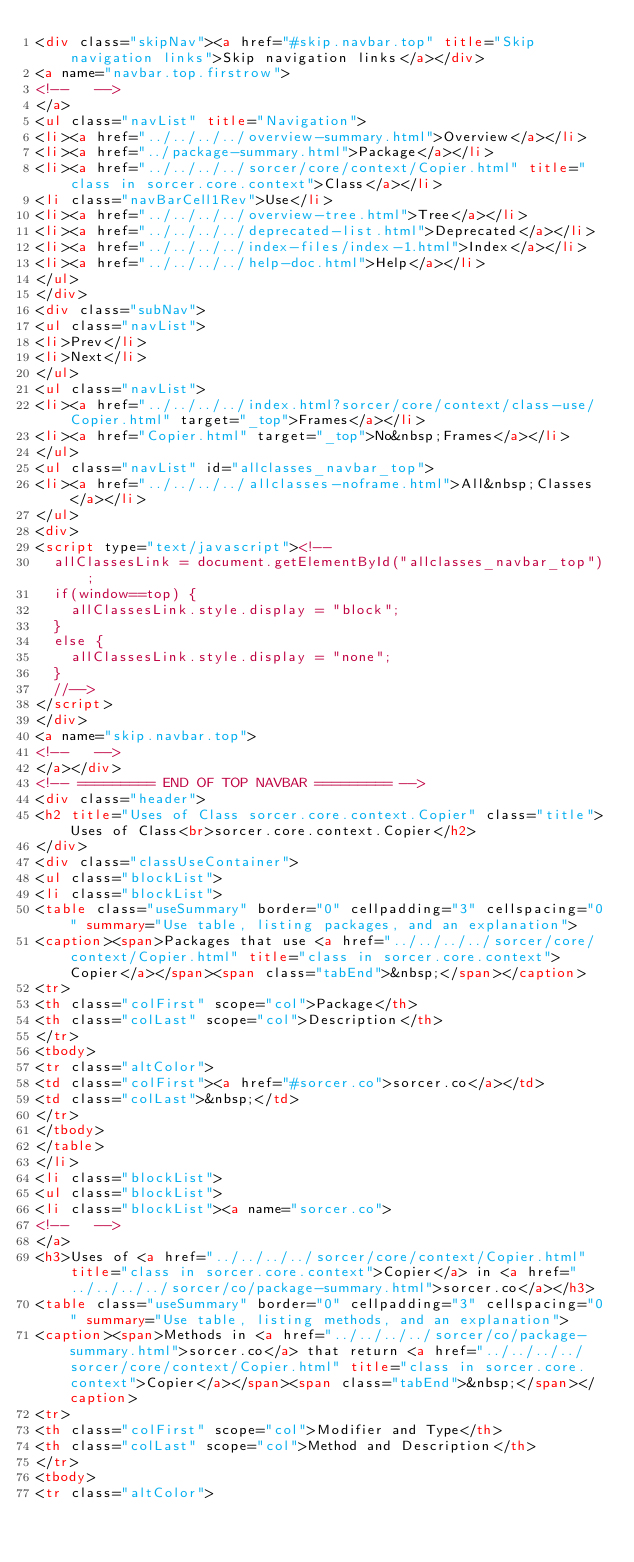Convert code to text. <code><loc_0><loc_0><loc_500><loc_500><_HTML_><div class="skipNav"><a href="#skip.navbar.top" title="Skip navigation links">Skip navigation links</a></div>
<a name="navbar.top.firstrow">
<!--   -->
</a>
<ul class="navList" title="Navigation">
<li><a href="../../../../overview-summary.html">Overview</a></li>
<li><a href="../package-summary.html">Package</a></li>
<li><a href="../../../../sorcer/core/context/Copier.html" title="class in sorcer.core.context">Class</a></li>
<li class="navBarCell1Rev">Use</li>
<li><a href="../../../../overview-tree.html">Tree</a></li>
<li><a href="../../../../deprecated-list.html">Deprecated</a></li>
<li><a href="../../../../index-files/index-1.html">Index</a></li>
<li><a href="../../../../help-doc.html">Help</a></li>
</ul>
</div>
<div class="subNav">
<ul class="navList">
<li>Prev</li>
<li>Next</li>
</ul>
<ul class="navList">
<li><a href="../../../../index.html?sorcer/core/context/class-use/Copier.html" target="_top">Frames</a></li>
<li><a href="Copier.html" target="_top">No&nbsp;Frames</a></li>
</ul>
<ul class="navList" id="allclasses_navbar_top">
<li><a href="../../../../allclasses-noframe.html">All&nbsp;Classes</a></li>
</ul>
<div>
<script type="text/javascript"><!--
  allClassesLink = document.getElementById("allclasses_navbar_top");
  if(window==top) {
    allClassesLink.style.display = "block";
  }
  else {
    allClassesLink.style.display = "none";
  }
  //-->
</script>
</div>
<a name="skip.navbar.top">
<!--   -->
</a></div>
<!-- ========= END OF TOP NAVBAR ========= -->
<div class="header">
<h2 title="Uses of Class sorcer.core.context.Copier" class="title">Uses of Class<br>sorcer.core.context.Copier</h2>
</div>
<div class="classUseContainer">
<ul class="blockList">
<li class="blockList">
<table class="useSummary" border="0" cellpadding="3" cellspacing="0" summary="Use table, listing packages, and an explanation">
<caption><span>Packages that use <a href="../../../../sorcer/core/context/Copier.html" title="class in sorcer.core.context">Copier</a></span><span class="tabEnd">&nbsp;</span></caption>
<tr>
<th class="colFirst" scope="col">Package</th>
<th class="colLast" scope="col">Description</th>
</tr>
<tbody>
<tr class="altColor">
<td class="colFirst"><a href="#sorcer.co">sorcer.co</a></td>
<td class="colLast">&nbsp;</td>
</tr>
</tbody>
</table>
</li>
<li class="blockList">
<ul class="blockList">
<li class="blockList"><a name="sorcer.co">
<!--   -->
</a>
<h3>Uses of <a href="../../../../sorcer/core/context/Copier.html" title="class in sorcer.core.context">Copier</a> in <a href="../../../../sorcer/co/package-summary.html">sorcer.co</a></h3>
<table class="useSummary" border="0" cellpadding="3" cellspacing="0" summary="Use table, listing methods, and an explanation">
<caption><span>Methods in <a href="../../../../sorcer/co/package-summary.html">sorcer.co</a> that return <a href="../../../../sorcer/core/context/Copier.html" title="class in sorcer.core.context">Copier</a></span><span class="tabEnd">&nbsp;</span></caption>
<tr>
<th class="colFirst" scope="col">Modifier and Type</th>
<th class="colLast" scope="col">Method and Description</th>
</tr>
<tbody>
<tr class="altColor"></code> 